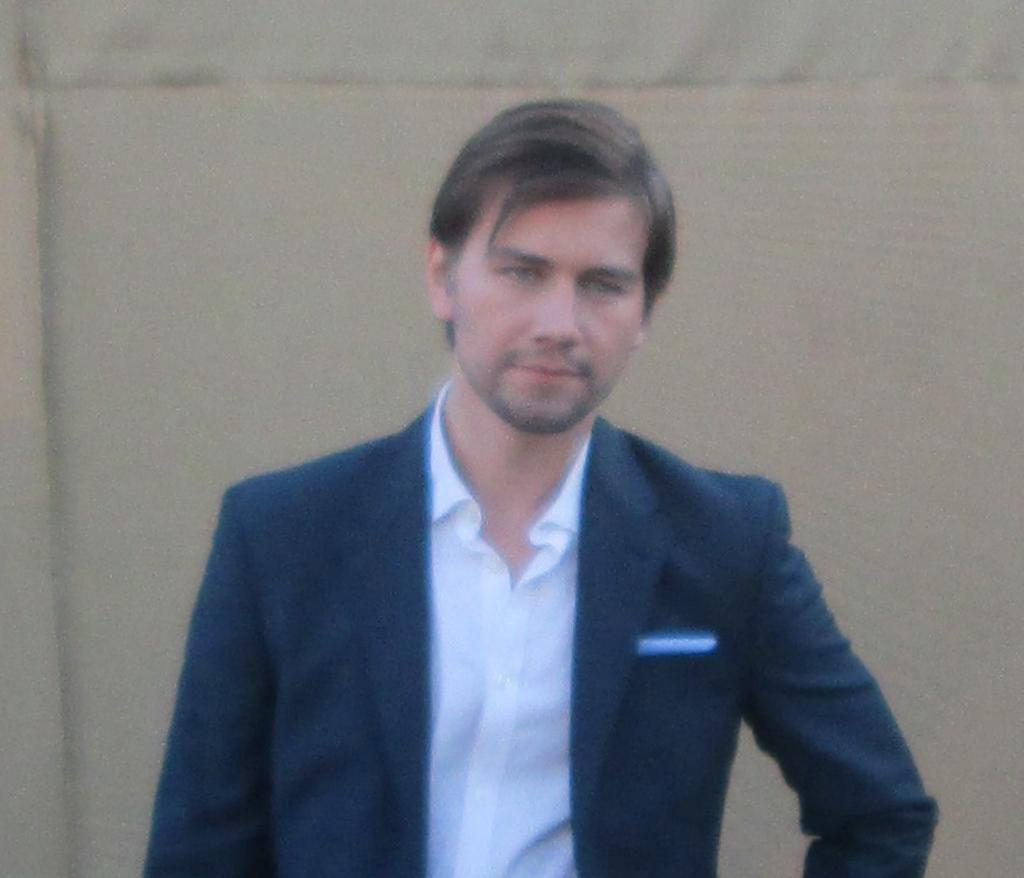What is the main subject of the image? There is a person in the image. What can be observed about the background of the image? The background of the image is light brown in color. What type of paste is the person using in the image? There is no paste present in the image; it only features a person and a light brown background. 